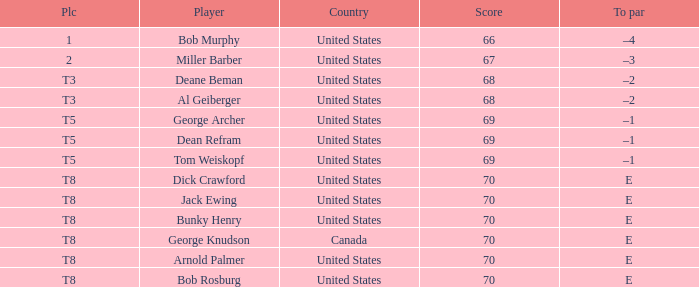When Bunky Henry placed t8, what was his To par? E. 